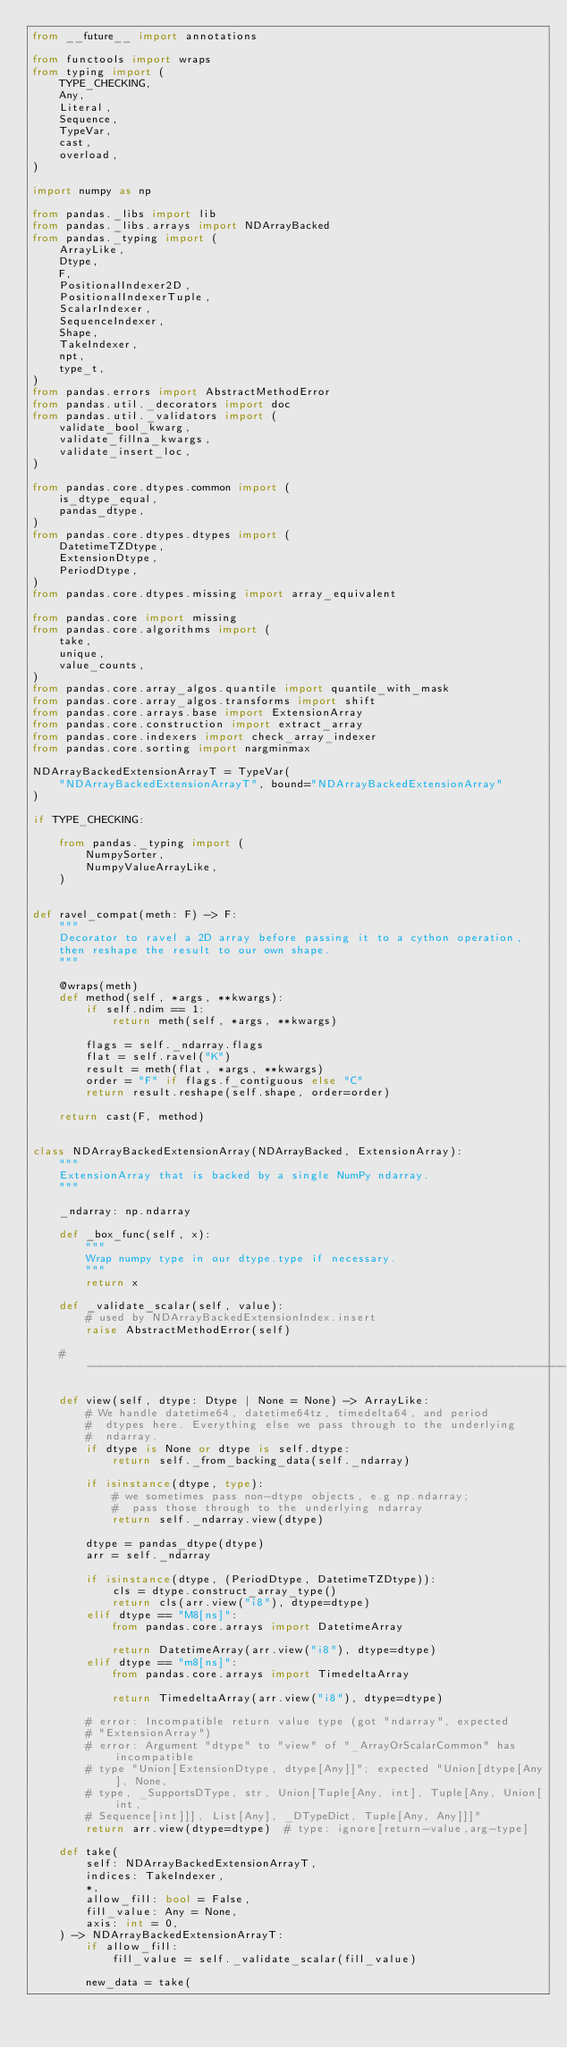<code> <loc_0><loc_0><loc_500><loc_500><_Python_>from __future__ import annotations

from functools import wraps
from typing import (
    TYPE_CHECKING,
    Any,
    Literal,
    Sequence,
    TypeVar,
    cast,
    overload,
)

import numpy as np

from pandas._libs import lib
from pandas._libs.arrays import NDArrayBacked
from pandas._typing import (
    ArrayLike,
    Dtype,
    F,
    PositionalIndexer2D,
    PositionalIndexerTuple,
    ScalarIndexer,
    SequenceIndexer,
    Shape,
    TakeIndexer,
    npt,
    type_t,
)
from pandas.errors import AbstractMethodError
from pandas.util._decorators import doc
from pandas.util._validators import (
    validate_bool_kwarg,
    validate_fillna_kwargs,
    validate_insert_loc,
)

from pandas.core.dtypes.common import (
    is_dtype_equal,
    pandas_dtype,
)
from pandas.core.dtypes.dtypes import (
    DatetimeTZDtype,
    ExtensionDtype,
    PeriodDtype,
)
from pandas.core.dtypes.missing import array_equivalent

from pandas.core import missing
from pandas.core.algorithms import (
    take,
    unique,
    value_counts,
)
from pandas.core.array_algos.quantile import quantile_with_mask
from pandas.core.array_algos.transforms import shift
from pandas.core.arrays.base import ExtensionArray
from pandas.core.construction import extract_array
from pandas.core.indexers import check_array_indexer
from pandas.core.sorting import nargminmax

NDArrayBackedExtensionArrayT = TypeVar(
    "NDArrayBackedExtensionArrayT", bound="NDArrayBackedExtensionArray"
)

if TYPE_CHECKING:

    from pandas._typing import (
        NumpySorter,
        NumpyValueArrayLike,
    )


def ravel_compat(meth: F) -> F:
    """
    Decorator to ravel a 2D array before passing it to a cython operation,
    then reshape the result to our own shape.
    """

    @wraps(meth)
    def method(self, *args, **kwargs):
        if self.ndim == 1:
            return meth(self, *args, **kwargs)

        flags = self._ndarray.flags
        flat = self.ravel("K")
        result = meth(flat, *args, **kwargs)
        order = "F" if flags.f_contiguous else "C"
        return result.reshape(self.shape, order=order)

    return cast(F, method)


class NDArrayBackedExtensionArray(NDArrayBacked, ExtensionArray):
    """
    ExtensionArray that is backed by a single NumPy ndarray.
    """

    _ndarray: np.ndarray

    def _box_func(self, x):
        """
        Wrap numpy type in our dtype.type if necessary.
        """
        return x

    def _validate_scalar(self, value):
        # used by NDArrayBackedExtensionIndex.insert
        raise AbstractMethodError(self)

    # ------------------------------------------------------------------------

    def view(self, dtype: Dtype | None = None) -> ArrayLike:
        # We handle datetime64, datetime64tz, timedelta64, and period
        #  dtypes here. Everything else we pass through to the underlying
        #  ndarray.
        if dtype is None or dtype is self.dtype:
            return self._from_backing_data(self._ndarray)

        if isinstance(dtype, type):
            # we sometimes pass non-dtype objects, e.g np.ndarray;
            #  pass those through to the underlying ndarray
            return self._ndarray.view(dtype)

        dtype = pandas_dtype(dtype)
        arr = self._ndarray

        if isinstance(dtype, (PeriodDtype, DatetimeTZDtype)):
            cls = dtype.construct_array_type()
            return cls(arr.view("i8"), dtype=dtype)
        elif dtype == "M8[ns]":
            from pandas.core.arrays import DatetimeArray

            return DatetimeArray(arr.view("i8"), dtype=dtype)
        elif dtype == "m8[ns]":
            from pandas.core.arrays import TimedeltaArray

            return TimedeltaArray(arr.view("i8"), dtype=dtype)

        # error: Incompatible return value type (got "ndarray", expected
        # "ExtensionArray")
        # error: Argument "dtype" to "view" of "_ArrayOrScalarCommon" has incompatible
        # type "Union[ExtensionDtype, dtype[Any]]"; expected "Union[dtype[Any], None,
        # type, _SupportsDType, str, Union[Tuple[Any, int], Tuple[Any, Union[int,
        # Sequence[int]]], List[Any], _DTypeDict, Tuple[Any, Any]]]"
        return arr.view(dtype=dtype)  # type: ignore[return-value,arg-type]

    def take(
        self: NDArrayBackedExtensionArrayT,
        indices: TakeIndexer,
        *,
        allow_fill: bool = False,
        fill_value: Any = None,
        axis: int = 0,
    ) -> NDArrayBackedExtensionArrayT:
        if allow_fill:
            fill_value = self._validate_scalar(fill_value)

        new_data = take(</code> 